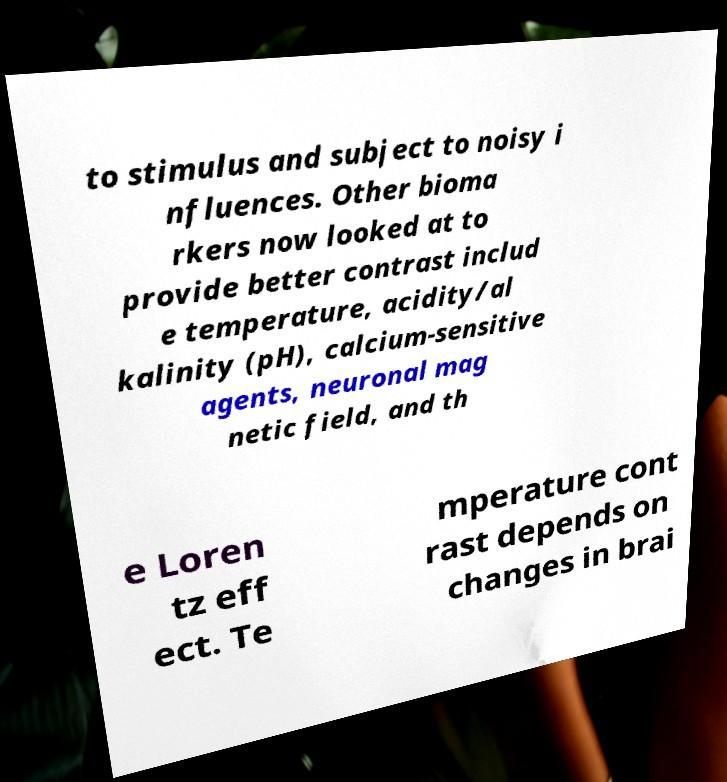Can you read and provide the text displayed in the image?This photo seems to have some interesting text. Can you extract and type it out for me? to stimulus and subject to noisy i nfluences. Other bioma rkers now looked at to provide better contrast includ e temperature, acidity/al kalinity (pH), calcium-sensitive agents, neuronal mag netic field, and th e Loren tz eff ect. Te mperature cont rast depends on changes in brai 